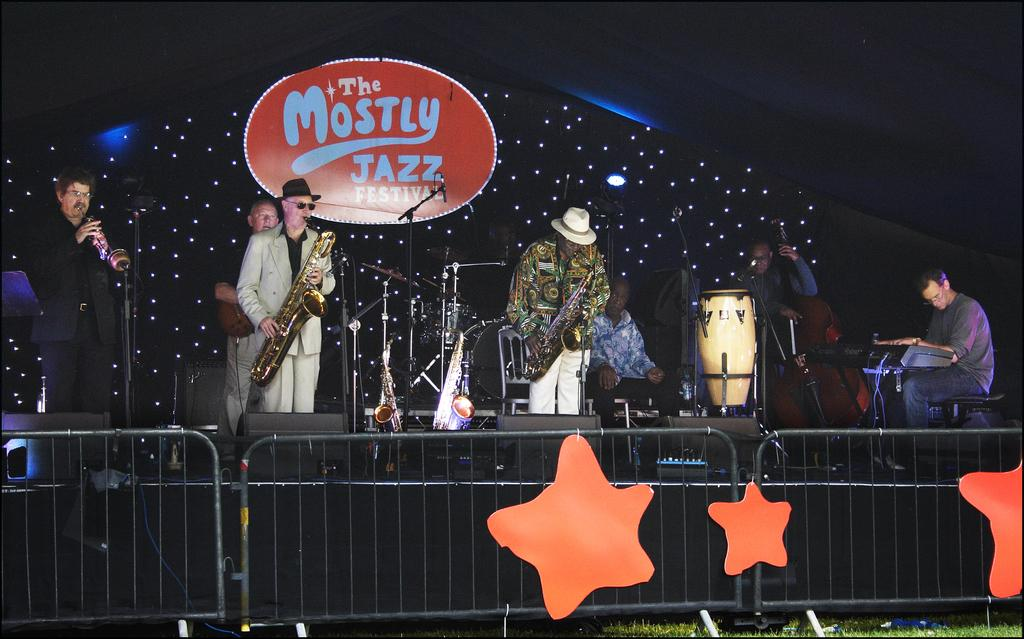What type of group is performing in the image? There are people in a music band performing in the image. Where are the people performing? The people are performing on a stage. What instruments are being played by the band members? One person is playing a saxophone, one person is playing a guitar, and one person is playing a piano. What type of power source is being used to fuel the instruments in the image? There is no information about the power source for the instruments in the image. Can you see any tomatoes being used as part of the performance in the image? There are no tomatoes present in the image; it features a music band performing on a stage. 